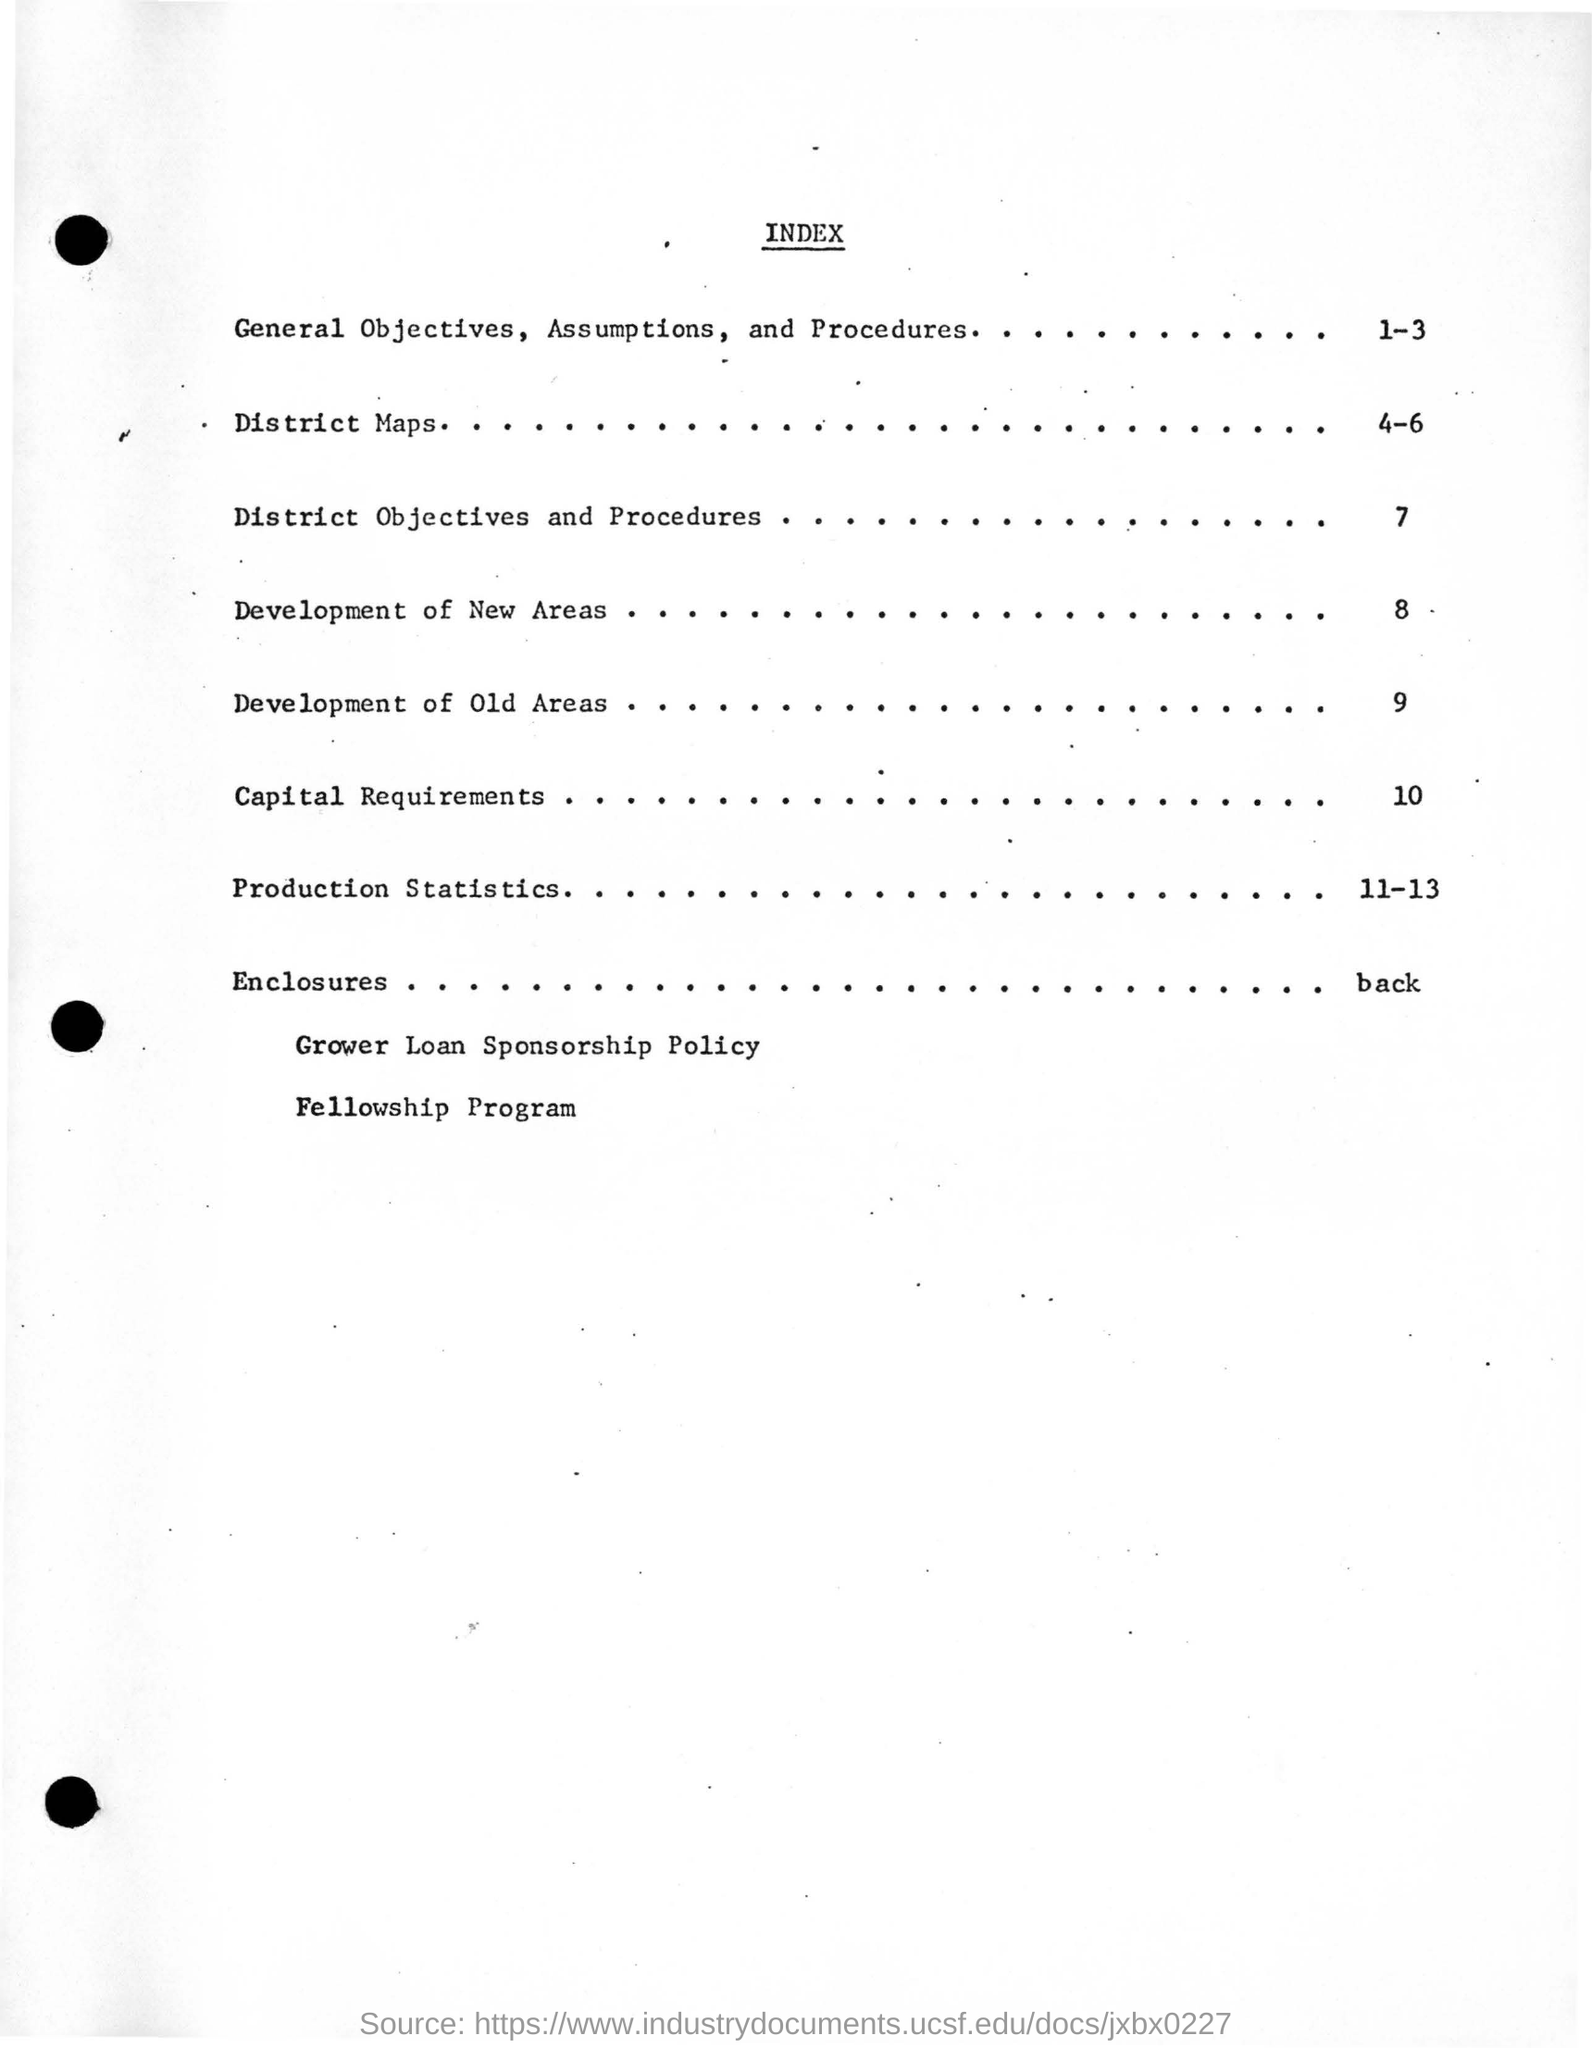List a handful of essential elements in this visual. The content on page 7 of the document is titled 'District Objectives and Procedures.' District Maps can be found on page 4-6. The text that follows is the last sentence of this document, which concerns the Fellowship Program. The heading of the document is "What is the heading of the document? index..". 